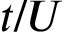Convert formula to latex. <formula><loc_0><loc_0><loc_500><loc_500>t / U</formula> 